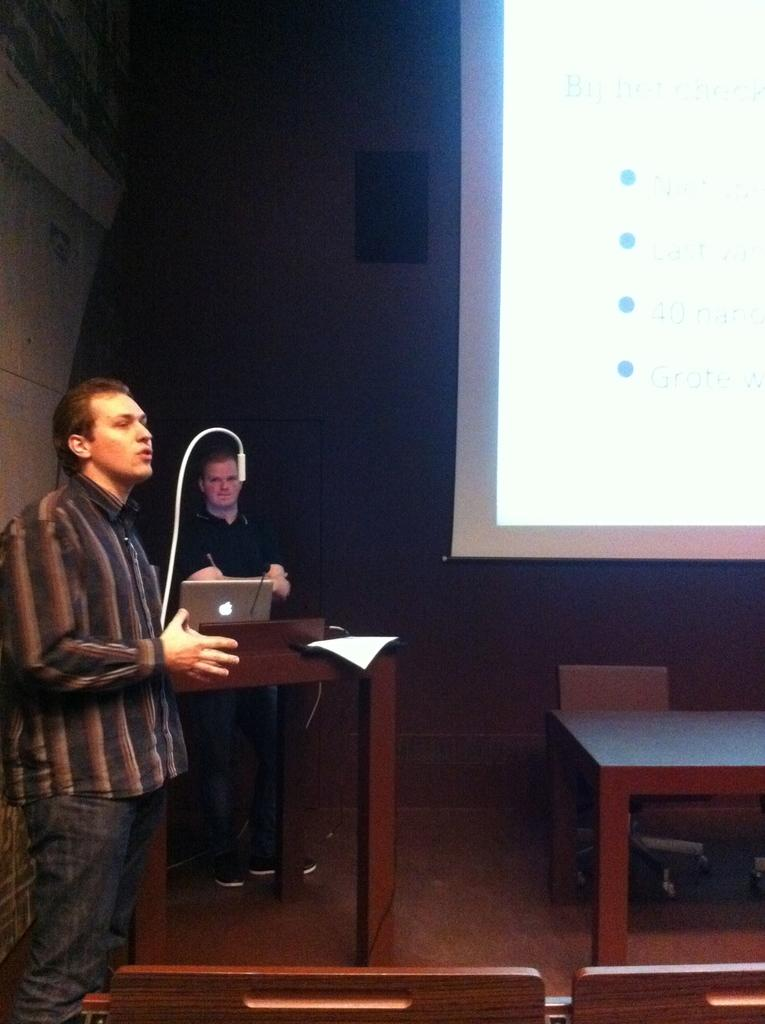What is the man in the image doing? There is a man standing and speaking in the image. Can you describe the other man in the image? There is another man standing near a podium in the image. What object does the man near the podium have? The man near the podium has a laptop. What can be seen in the background of the image? There is a table, a screen, a speaker, and a wall in the background of the image. What type of lumber is being used to construct the scale in the image? There is no scale or lumber present in the image. How does the man answer the questions during his speech in the image? The image does not show the man answering any questions, only speaking. 